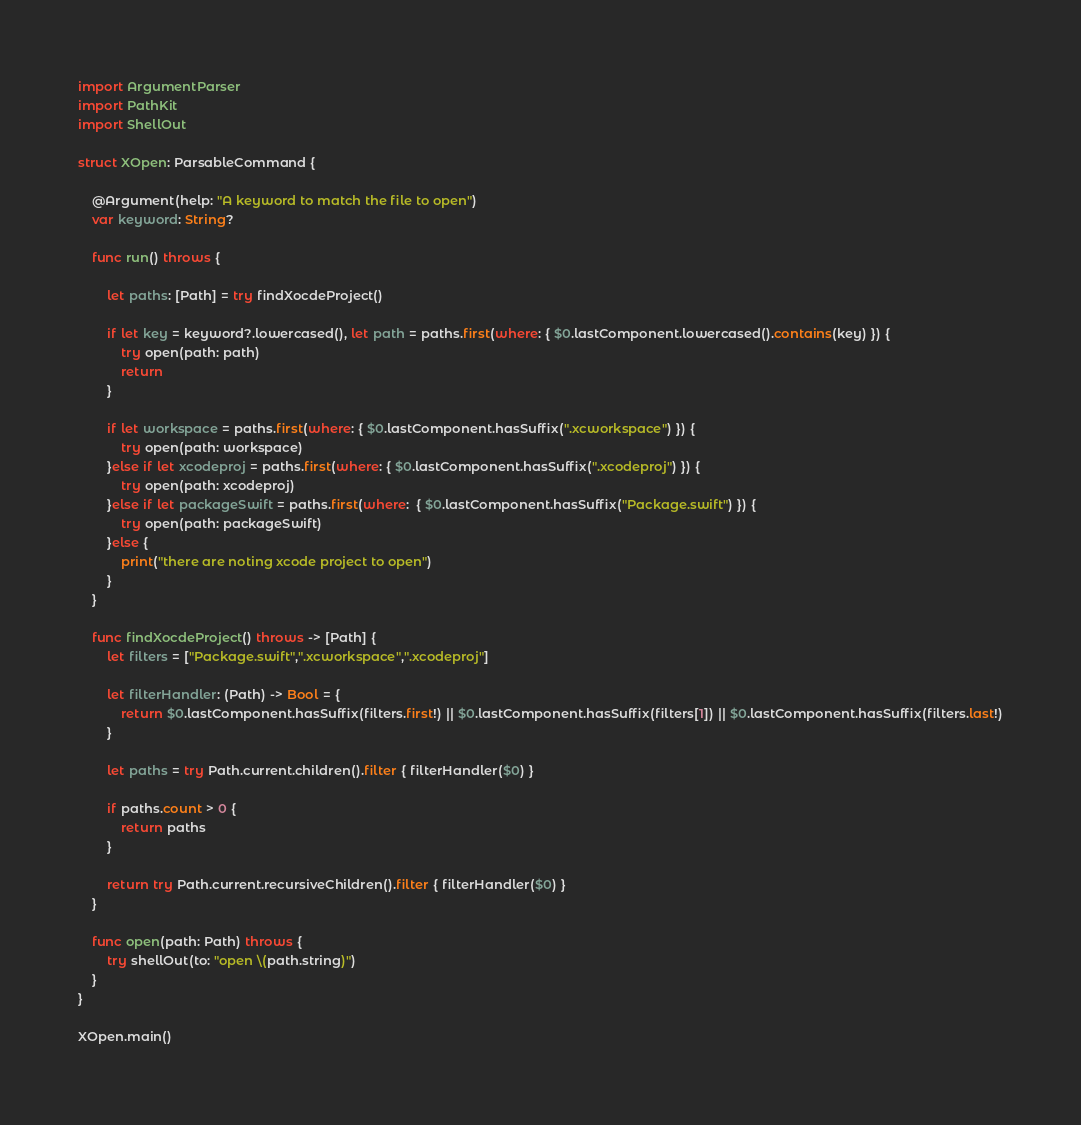Convert code to text. <code><loc_0><loc_0><loc_500><loc_500><_Swift_>
import ArgumentParser
import PathKit
import ShellOut

struct XOpen: ParsableCommand {
    
    @Argument(help: "A keyword to match the file to open")
    var keyword: String?
    
    func run() throws {
    
        let paths: [Path] = try findXocdeProject()
        
        if let key = keyword?.lowercased(), let path = paths.first(where: { $0.lastComponent.lowercased().contains(key) }) {
            try open(path: path)
            return
        }
        
        if let workspace = paths.first(where: { $0.lastComponent.hasSuffix(".xcworkspace") }) {
            try open(path: workspace)
        }else if let xcodeproj = paths.first(where: { $0.lastComponent.hasSuffix(".xcodeproj") }) {
            try open(path: xcodeproj)
        }else if let packageSwift = paths.first(where:  { $0.lastComponent.hasSuffix("Package.swift") }) {
            try open(path: packageSwift)
        }else {
            print("there are noting xcode project to open")
        }
    }
    
    func findXocdeProject() throws -> [Path] {
        let filters = ["Package.swift",".xcworkspace",".xcodeproj"]
        
        let filterHandler: (Path) -> Bool = {
            return $0.lastComponent.hasSuffix(filters.first!) || $0.lastComponent.hasSuffix(filters[1]) || $0.lastComponent.hasSuffix(filters.last!)
        }
        
        let paths = try Path.current.children().filter { filterHandler($0) }
        
        if paths.count > 0 {
            return paths
        }
        
        return try Path.current.recursiveChildren().filter { filterHandler($0) }
    }
    
    func open(path: Path) throws {
        try shellOut(to: "open \(path.string)")
    }
}

XOpen.main()
</code> 